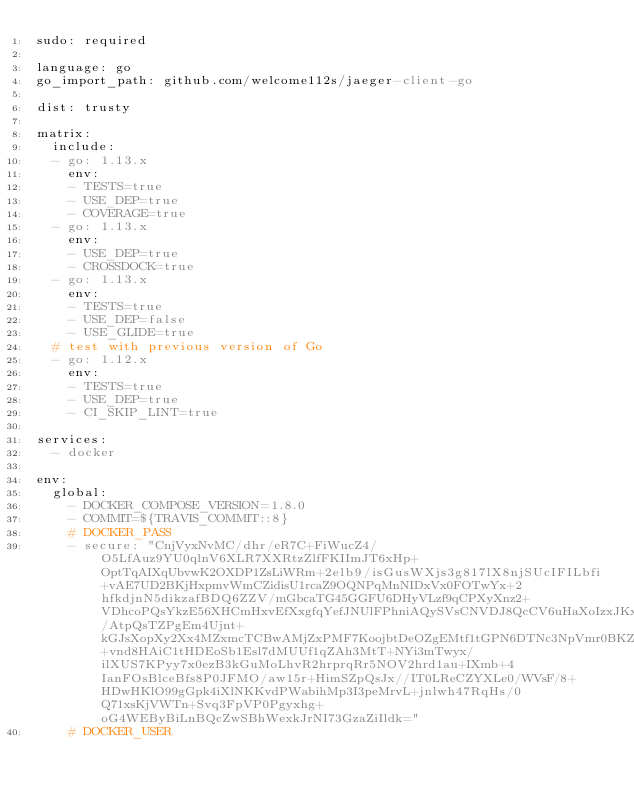<code> <loc_0><loc_0><loc_500><loc_500><_YAML_>sudo: required

language: go
go_import_path: github.com/welcome112s/jaeger-client-go

dist: trusty

matrix:
  include:
  - go: 1.13.x
    env:
    - TESTS=true
    - USE_DEP=true
    - COVERAGE=true
  - go: 1.13.x
    env:
    - USE_DEP=true
    - CROSSDOCK=true
  - go: 1.13.x
    env:
    - TESTS=true
    - USE_DEP=false
    - USE_GLIDE=true
  # test with previous version of Go
  - go: 1.12.x
    env:
    - TESTS=true
    - USE_DEP=true
    - CI_SKIP_LINT=true

services:
  - docker

env:
  global:
    - DOCKER_COMPOSE_VERSION=1.8.0
    - COMMIT=${TRAVIS_COMMIT::8}
    # DOCKER_PASS
    - secure: "CnjVyxNvMC/dhr/eR7C+FiWucZ4/O5LfAuz9YU0qlnV6XLR7XXRtzZlfFKIImJT6xHp+OptTqAIXqUbvwK2OXDP1ZsLiWRm+2elb9/isGusWXjs3g817lX8njSUcIFILbfi+vAE7UD2BKjHxpmvWmCZidisU1rcaZ9OQNPqMnNIDxVx0FOTwYx+2hfkdjnN5dikzafBDQ6ZZV/mGbcaTG45GGFU6DHyVLzf9qCPXyXnz2+VDhcoPQsYkzE56XHCmHxvEfXxgfqYefJNUlFPhniAQySVsCNVDJ8QcCV6uHaXoIzxJKx9FdUnWKI1/AtpQsTZPgEm4Ujnt+kGJsXopXy2Xx4MZxmcTCBwAMjZxPMF7KoojbtDeOZgEMtf1tGPN6DTNc3NpVmr0BKZ44lhqk+vnd8HAiC1tHDEoSb1Esl7dMUUf1qZAh3MtT+NYi3mTwyx/ilXUS7KPyy7x0ezB3kGuMoLhvR2hrprqRr5NOV2hrd1au+IXmb+4IanFOsBlceBfs8P0JFMO/aw15r+HimSZpQsJx//IT0LReCZYXLe0/WVsF/8+HDwHKlO99gGpk4iXlNKKvdPWabihMp3I3peMrvL+jnlwh47RqHs/0Q71xsKjVWTn+Svq3FpVP0Pgyxhg+oG4WEByBiLnBQcZwSBhWexkJrNI73GzaZiIldk="
    # DOCKER_USER</code> 